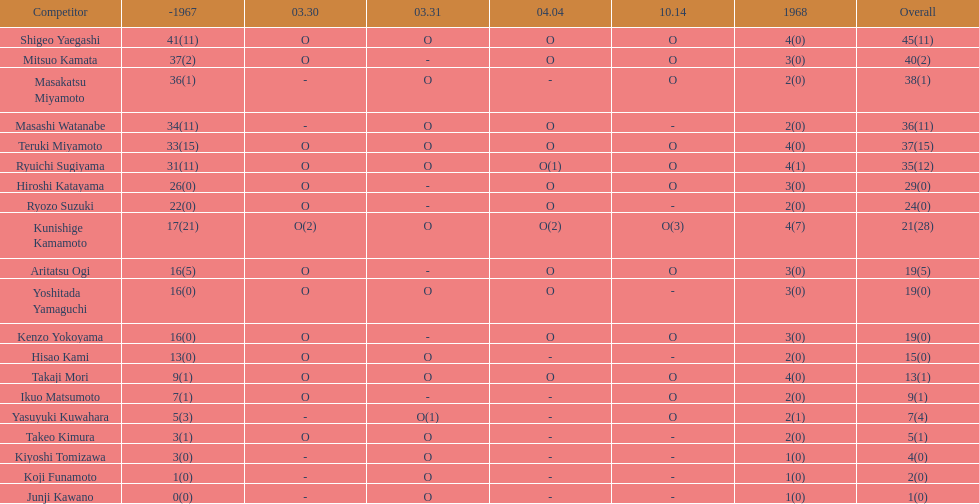Has mitsuo kamata achieved beyond 40 total points? No. 